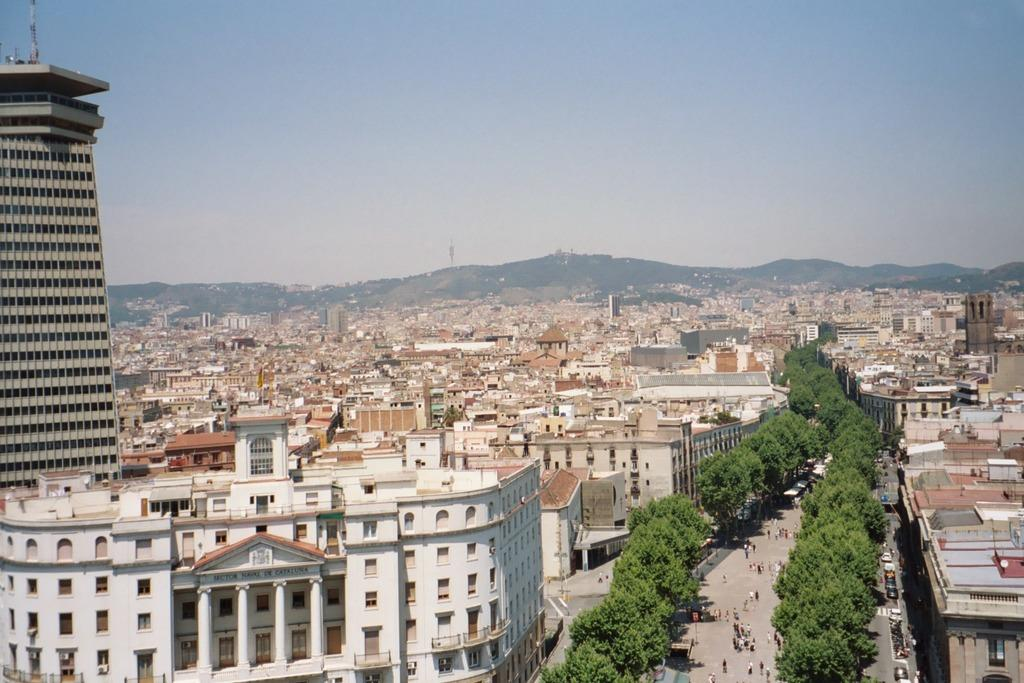What type of structures can be seen in the image? There is a group of buildings in the image. What other natural elements are present in the image? There are trees in the image. Are there any people visible in the image? Yes, there are persons in the image. What can be seen in the distance in the image? There are mountains visible in the background of the image. What is visible at the top of the image? The sky is visible at the top of the image. What type of picture is being distributed in the image? There is no reference to a picture or distribution in the image; it features a group of buildings, trees, persons, mountains, and the sky. 